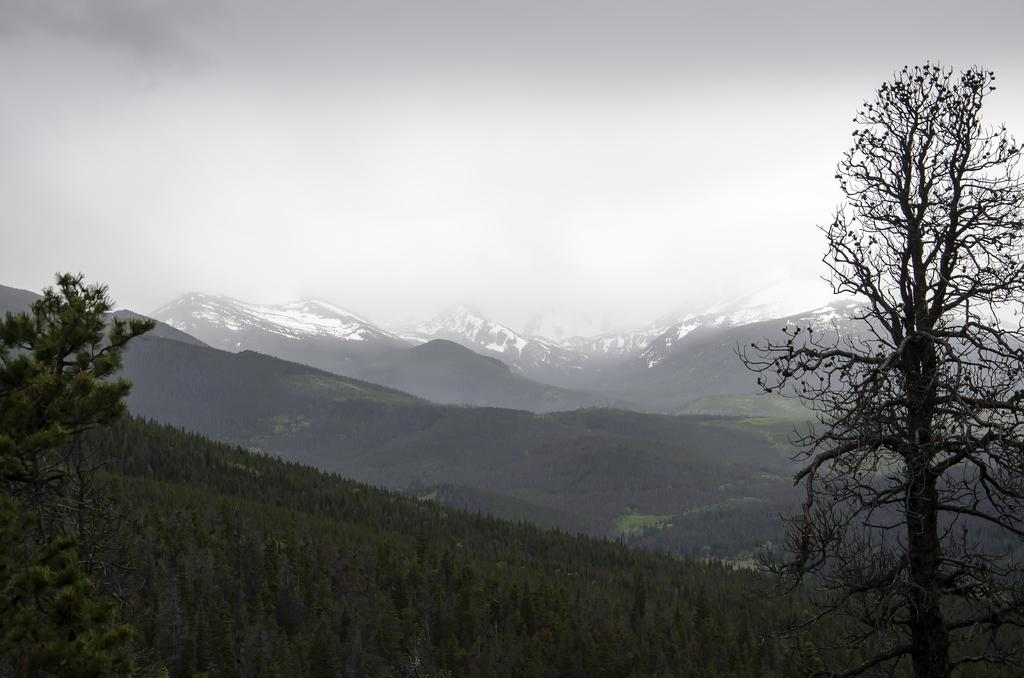Where was the image taken? The image was clicked outside. What geographical features can be seen in the image? There are mountains in the image. What is the condition of the mountains? The mountains have snow on them. What atmospheric condition is present in the image? There is fog in the image. What type of vegetation is present at the bottom of the image? There are plants and trees at the bottom of the image. What part of the natural environment is visible in the image? The sky is visible at the top of the image. What type of powder is being used to clean the trees in the image? There is no powder or cleaning activity present in the image. What is the name of the person who laid the eggs in the image? There are no eggs or people present in the image. 